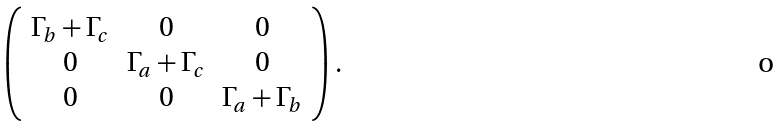Convert formula to latex. <formula><loc_0><loc_0><loc_500><loc_500>\left ( \begin{array} { c c c } \Gamma _ { b } + \Gamma _ { c } & 0 & 0 \\ 0 & \Gamma _ { a } + \Gamma _ { c } & 0 \\ 0 & 0 & \Gamma _ { a } + \Gamma _ { b } \end{array} \right ) .</formula> 